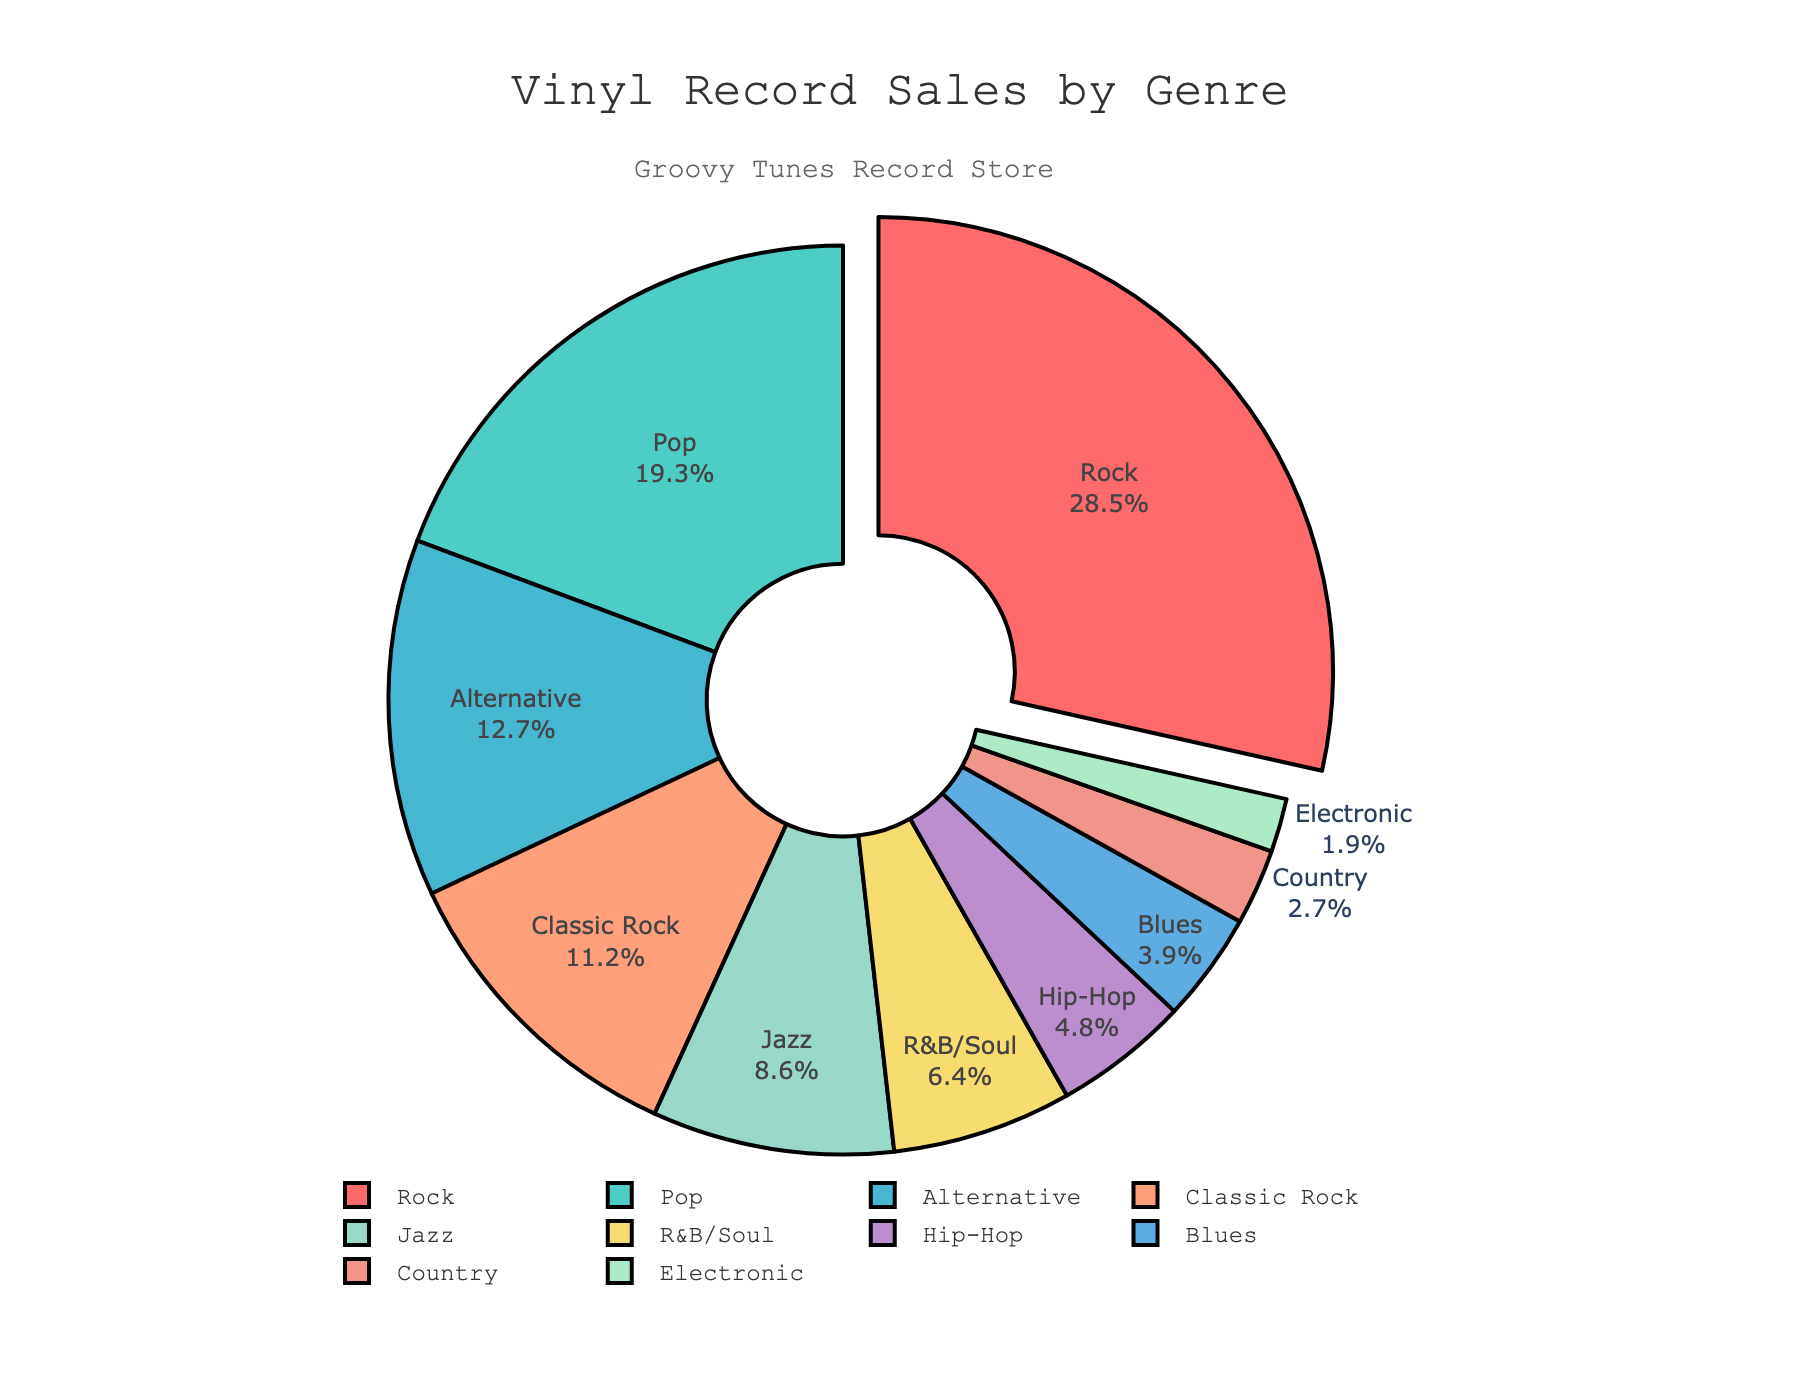What genre has the highest percentage of vinyl record sales? Look at the pie chart and identify the segment with the largest proportion. The segment labeled "Rock" has the highest percentage next to it.
Answer: Rock Which genre has the smallest share of vinyl record sales? Focus on the segment with the smallest percentage label. The "Electronic" genre has the smallest percentage at 1.9%.
Answer: Electronic What is the combined percentage of Rock and Classic Rock sales? Add the percentages of Rock and Classic Rock: 28.5% (Rock) + 11.2% (Classic Rock) = 39.7%.
Answer: 39.7% Is the percentage of Pop sales greater than Alternative sales? Compare the percentage values next to "Pop" and "Alternative": Pop is 19.3%, and Alternative is 12.7%. Pop is greater.
Answer: Yes How much more in percentage is Jazz compared to Country? Find the difference between the percentages for Jazz and Country: 8.6% (Jazz) - 2.7% (Country) = 5.9%.
Answer: 5.9% Which genre is pulled slightly outward from the pie chart? Visually inspect the pie chart for any segment that appears detached or pulled out. The "Rock" segment is pulled outward.
Answer: Rock Between R&B/Soul and Hip-Hop, which genre has a higher percentage of vinyl record sales? Look at the percentages next to R&B/Soul and Hip-Hop: R&B/Soul is 6.4%, and Hip-Hop is 4.8%. R&B/Soul is higher.
Answer: R&B/Soul What are the total percentages of Jazz, Blues, and Country sales together? Add the percentages of Jazz, Blues, and Country: 8.6% (Jazz) + 3.9% (Blues) + 2.7% (Country) = 15.2%.
Answer: 15.2% How does the percentage of Rock compare to the combined percentages of Hip-Hop and Blues? Compare 28.5% (Rock) to the sum of Hip-Hop and Blues: 4.8% (Hip-Hop) + 3.9% (Blues) = 8.7%. 28.5% is greater than 8.7%.
Answer: Rock is greater What color is the segment representing Pop sales? Look at the color of the segment labeled "Pop" in the pie chart. It is turquoise/green.
Answer: Turquoise/Green 